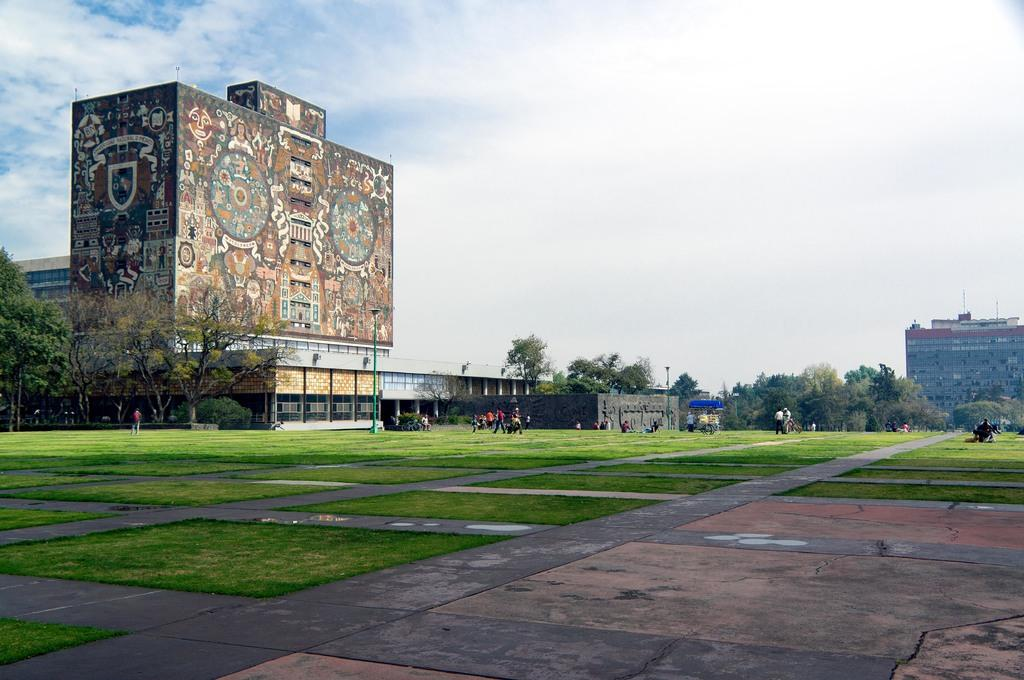What type of structures can be seen in the image? There are buildings in the image. What natural elements are present in the image? There are trees and grass on the surface in the image. What man-made objects can be seen in the image? There are poles in the image. What are the people in the image doing? There are people walking in the image. What is the path used for in the image? The path is likely used for walking or transportation. What can be seen in the background of the image? The sky is visible in the background of the image. What type of religious ceremony is taking place in the image? There is no indication of a religious ceremony in the image; it features buildings, trees, poles, people walking, grass, a path, and the sky. How does the bee interact with the people walking in the image? There are no bees present in the image; it only features buildings, trees, poles, people walking, grass, a path, and the sky. 